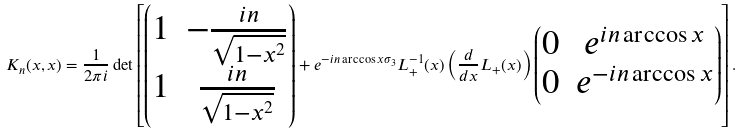Convert formula to latex. <formula><loc_0><loc_0><loc_500><loc_500>K _ { n } ( x , x ) = \frac { 1 } { 2 \pi i } \det \left [ \begin{pmatrix} 1 & - \frac { i n } { \sqrt { 1 - x ^ { 2 } } } \\ 1 & \frac { i n } { \sqrt { 1 - x ^ { 2 } } } \end{pmatrix} + e ^ { - i n \arccos x \sigma _ { 3 } } L _ { + } ^ { - 1 } ( x ) \left ( \frac { d } { d x } L _ { + } ( x ) \right ) \begin{pmatrix} 0 & e ^ { i n \arccos x } \\ 0 & e ^ { - i n \arccos x } \end{pmatrix} \right ] .</formula> 